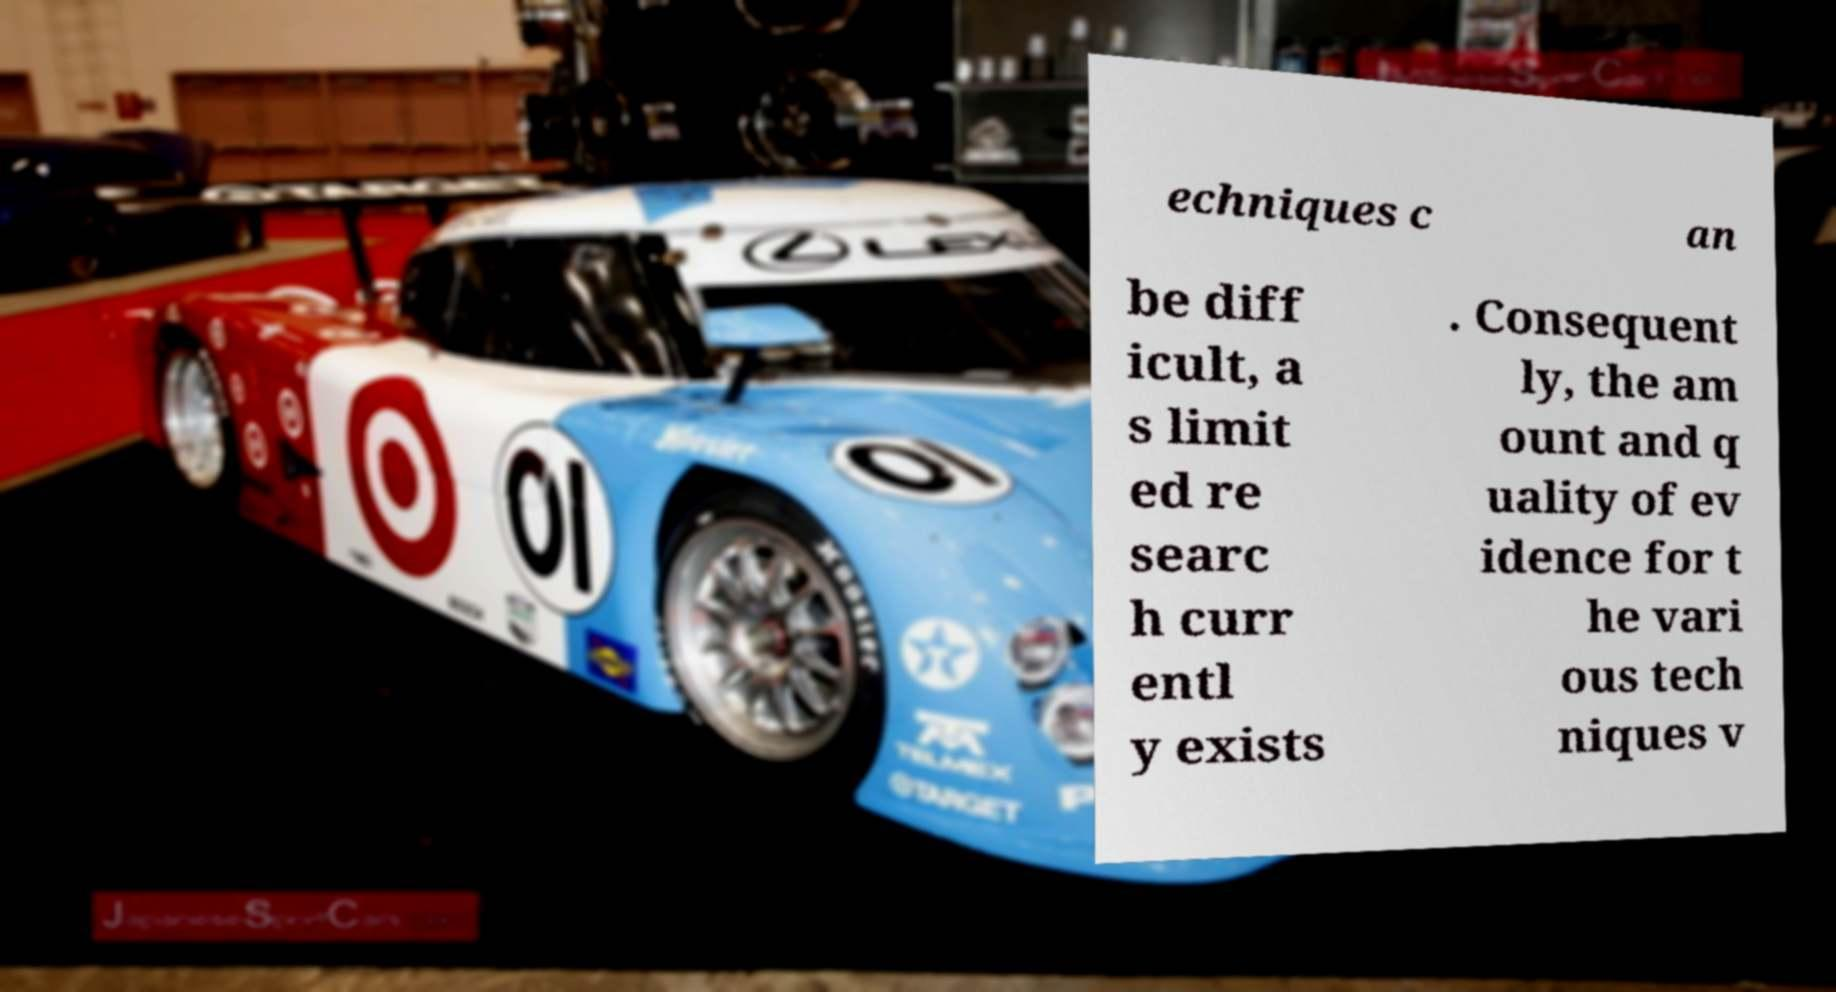Can you accurately transcribe the text from the provided image for me? echniques c an be diff icult, a s limit ed re searc h curr entl y exists . Consequent ly, the am ount and q uality of ev idence for t he vari ous tech niques v 